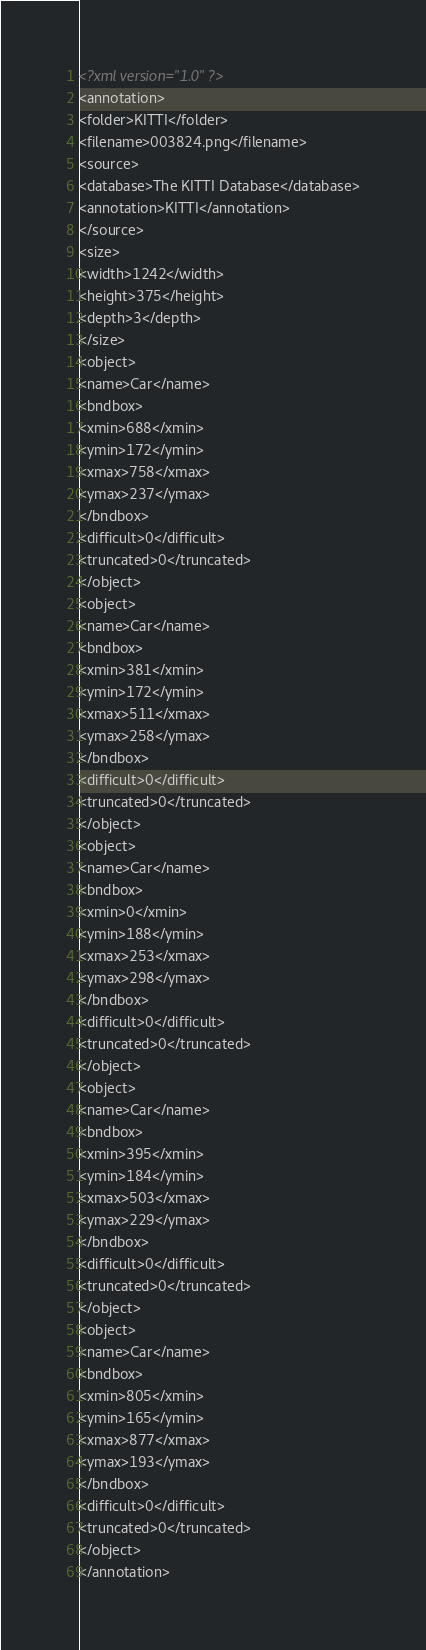<code> <loc_0><loc_0><loc_500><loc_500><_XML_><?xml version="1.0" ?>
<annotation>
<folder>KITTI</folder>
<filename>003824.png</filename>
<source>
<database>The KITTI Database</database>
<annotation>KITTI</annotation>
</source>
<size>
<width>1242</width>
<height>375</height>
<depth>3</depth>
</size>
<object>
<name>Car</name>
<bndbox>
<xmin>688</xmin>
<ymin>172</ymin>
<xmax>758</xmax>
<ymax>237</ymax>
</bndbox>
<difficult>0</difficult>
<truncated>0</truncated>
</object>
<object>
<name>Car</name>
<bndbox>
<xmin>381</xmin>
<ymin>172</ymin>
<xmax>511</xmax>
<ymax>258</ymax>
</bndbox>
<difficult>0</difficult>
<truncated>0</truncated>
</object>
<object>
<name>Car</name>
<bndbox>
<xmin>0</xmin>
<ymin>188</ymin>
<xmax>253</xmax>
<ymax>298</ymax>
</bndbox>
<difficult>0</difficult>
<truncated>0</truncated>
</object>
<object>
<name>Car</name>
<bndbox>
<xmin>395</xmin>
<ymin>184</ymin>
<xmax>503</xmax>
<ymax>229</ymax>
</bndbox>
<difficult>0</difficult>
<truncated>0</truncated>
</object>
<object>
<name>Car</name>
<bndbox>
<xmin>805</xmin>
<ymin>165</ymin>
<xmax>877</xmax>
<ymax>193</ymax>
</bndbox>
<difficult>0</difficult>
<truncated>0</truncated>
</object>
</annotation>
</code> 